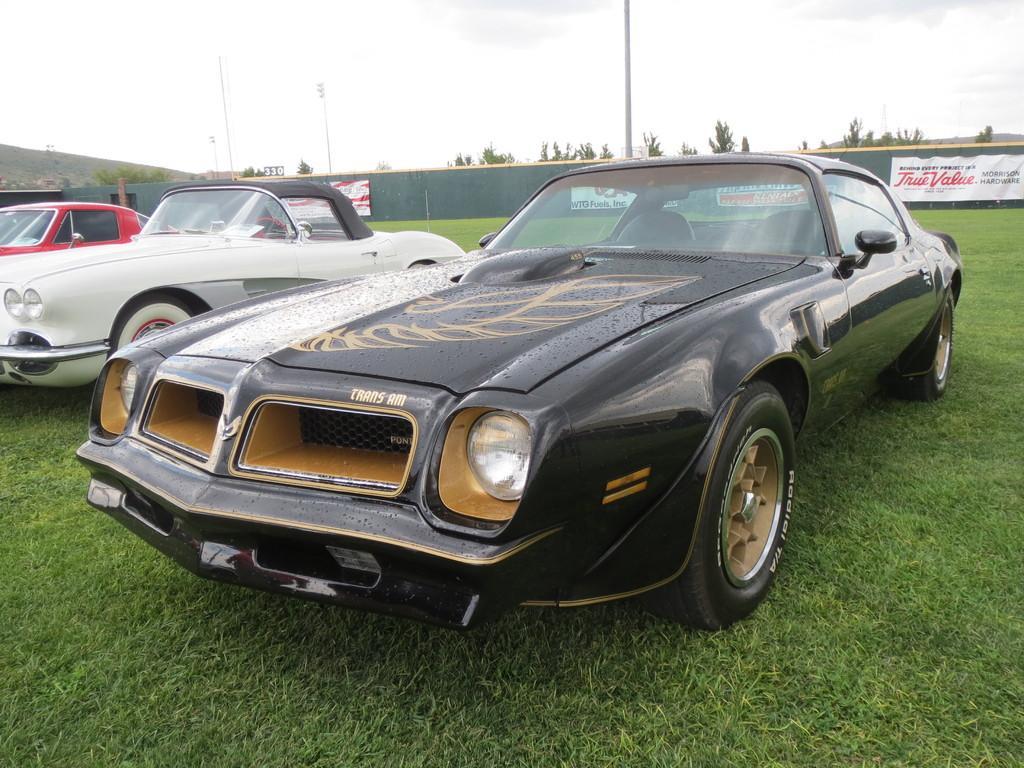Describe this image in one or two sentences. In this image there are three cars which are parked on the grass that is in the park and the first car is black in color and it has some image which is printed on the front dome, the second car is white in color and it has black at the top and third car is red in color and we can see a wall at the back which is green in color and which also has boarding saying that true value and there are also some poles and there are also some trees which are placed at the back of this wall and towards left we can see some hill which is extended towards the other side. 